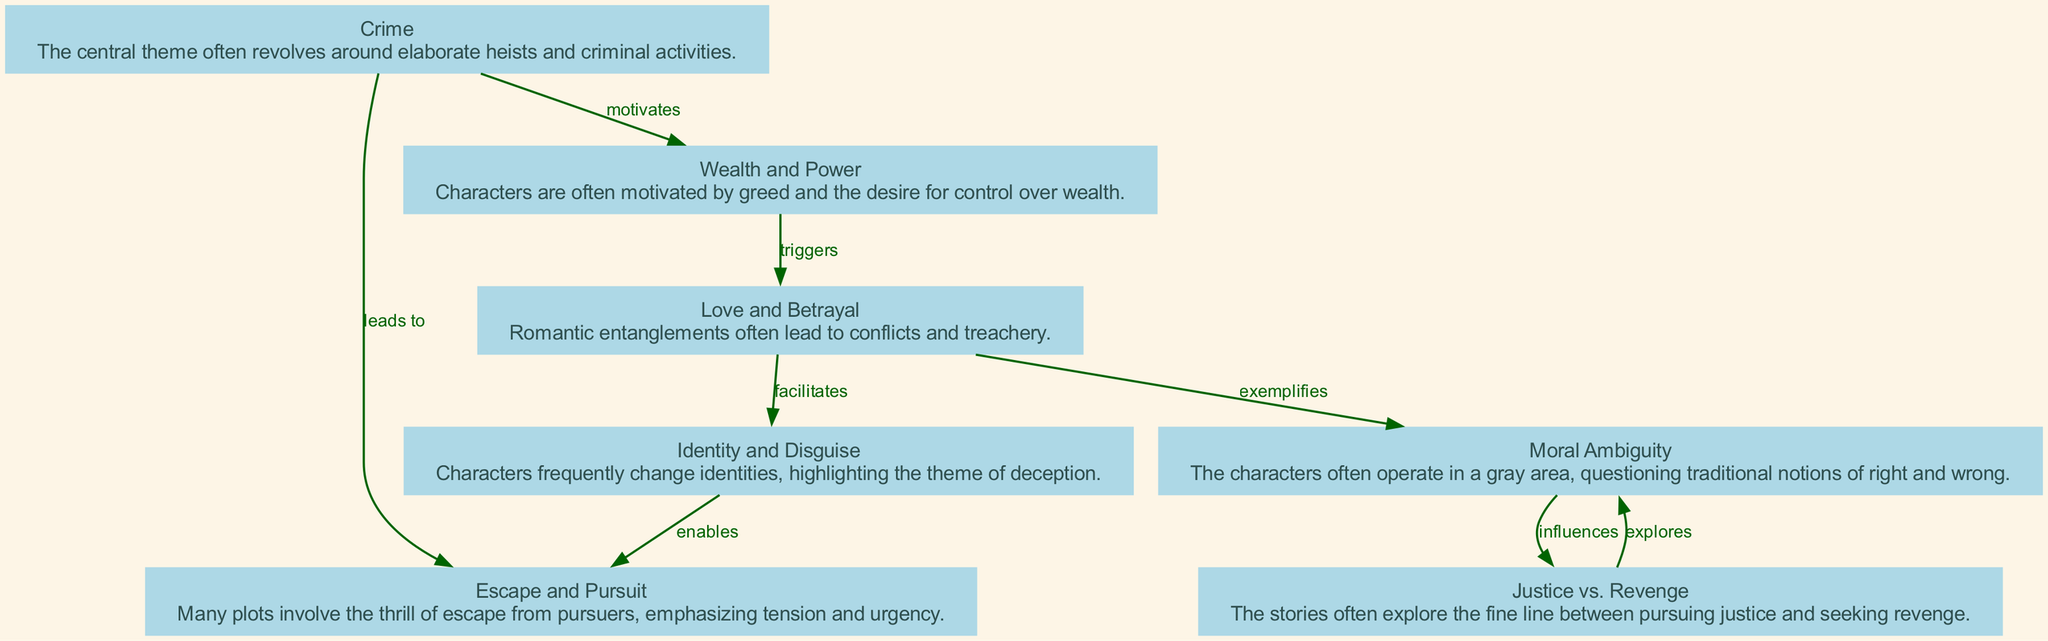What is the central theme of Diabolik stories? The central theme, as indicated by the diagram, is "Crime." This is represented by the first node, which highlights that many stories revolve around criminal activities and heists.
Answer: Crime Which theme exemplifies the idea of deception? The theme associated with deception in the diagram is "Identity and Disguise," as described in the third node. This node specifically focuses on characters' frequent changes of identity.
Answer: Identity and Disguise How many nodes are present in the diagram? By counting the elements listed in the diagram, there are a total of seven distinct themes represented as nodes. This can be seen directly from the data provided.
Answer: 7 What relationship exists between "Love and Betrayal" and "Moral Ambiguity"? The diagram shows that "Love and Betrayal" facilitates "Identity and Disguise." While there is no direct edge between the two, both themes reflect complexities in character motivations that may lead to moral ambiguity indirectly.
Answer: Facilitates (indirectly) Which theme is influenced by "Justice vs. Revenge"? According to the diagram, "Moral Ambiguity" is influenced by "Justice vs. Revenge." The line connecting these two nodes illustrates this relationship clearly.
Answer: Moral Ambiguity What does "Wealth and Power" trigger? The diagram clearly identifies that "Wealth and Power" triggers "Love and Betrayal," as shown by the directed edge between these two nodes.
Answer: Love and Betrayal Which two themes lead to "Escape and Pursuit"? The diagram indicates that "Crime" leads to "Escape and Pursuit" and that "Love and Betrayal" also facilitates the circumstances for escape plots. Both relationships are key to generating pursuit scenarios.
Answer: Crime, Love and Betrayal What is the main motivation behind the characters' actions according to the diagram? The diagram posits that "Wealth and Power" serves as the main motivation for characters, directing them towards various actions depicted in the storylines.
Answer: Wealth and Power 